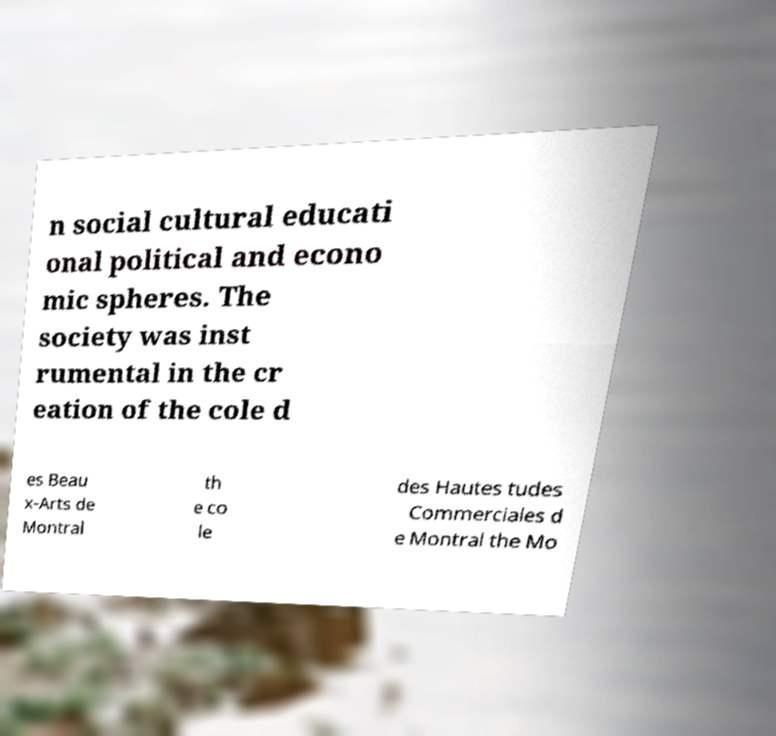For documentation purposes, I need the text within this image transcribed. Could you provide that? n social cultural educati onal political and econo mic spheres. The society was inst rumental in the cr eation of the cole d es Beau x-Arts de Montral th e co le des Hautes tudes Commerciales d e Montral the Mo 